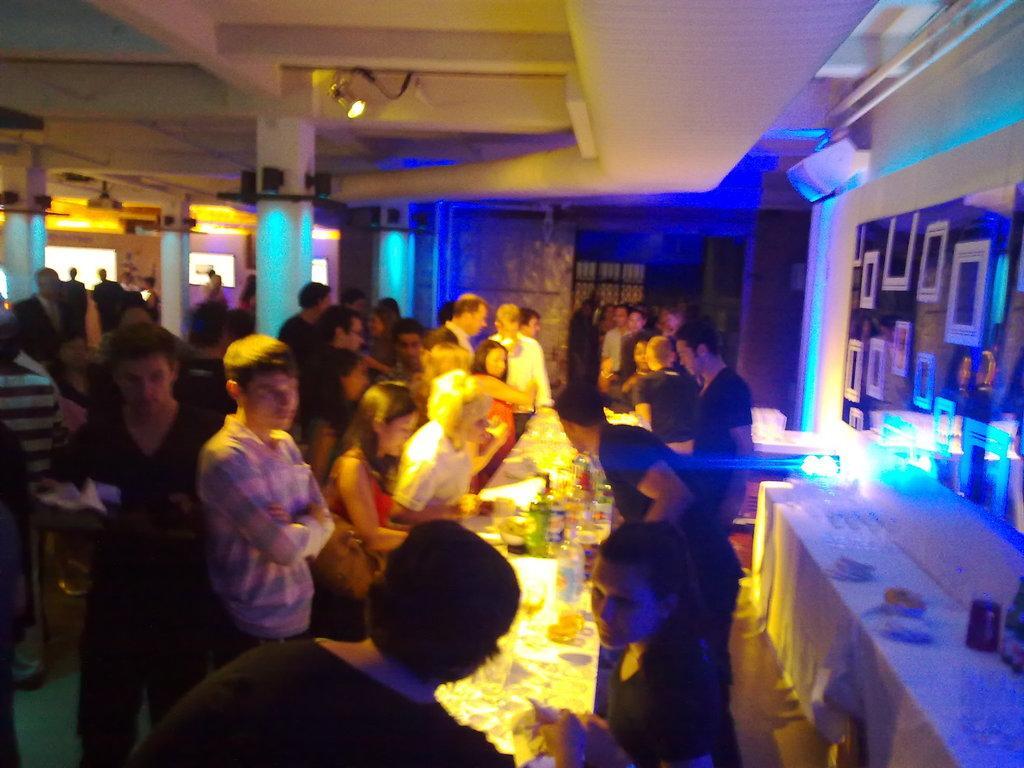Can you describe this image briefly? In this image we can see some group of persons who are standing near the table on which there are some bottles, drinks and there are some persons standing behind the table and supplying some drinks, at the background of the image there are some pillars, lights, wall, at the right side of the image there is A. C. and table on which there are some bottles. 